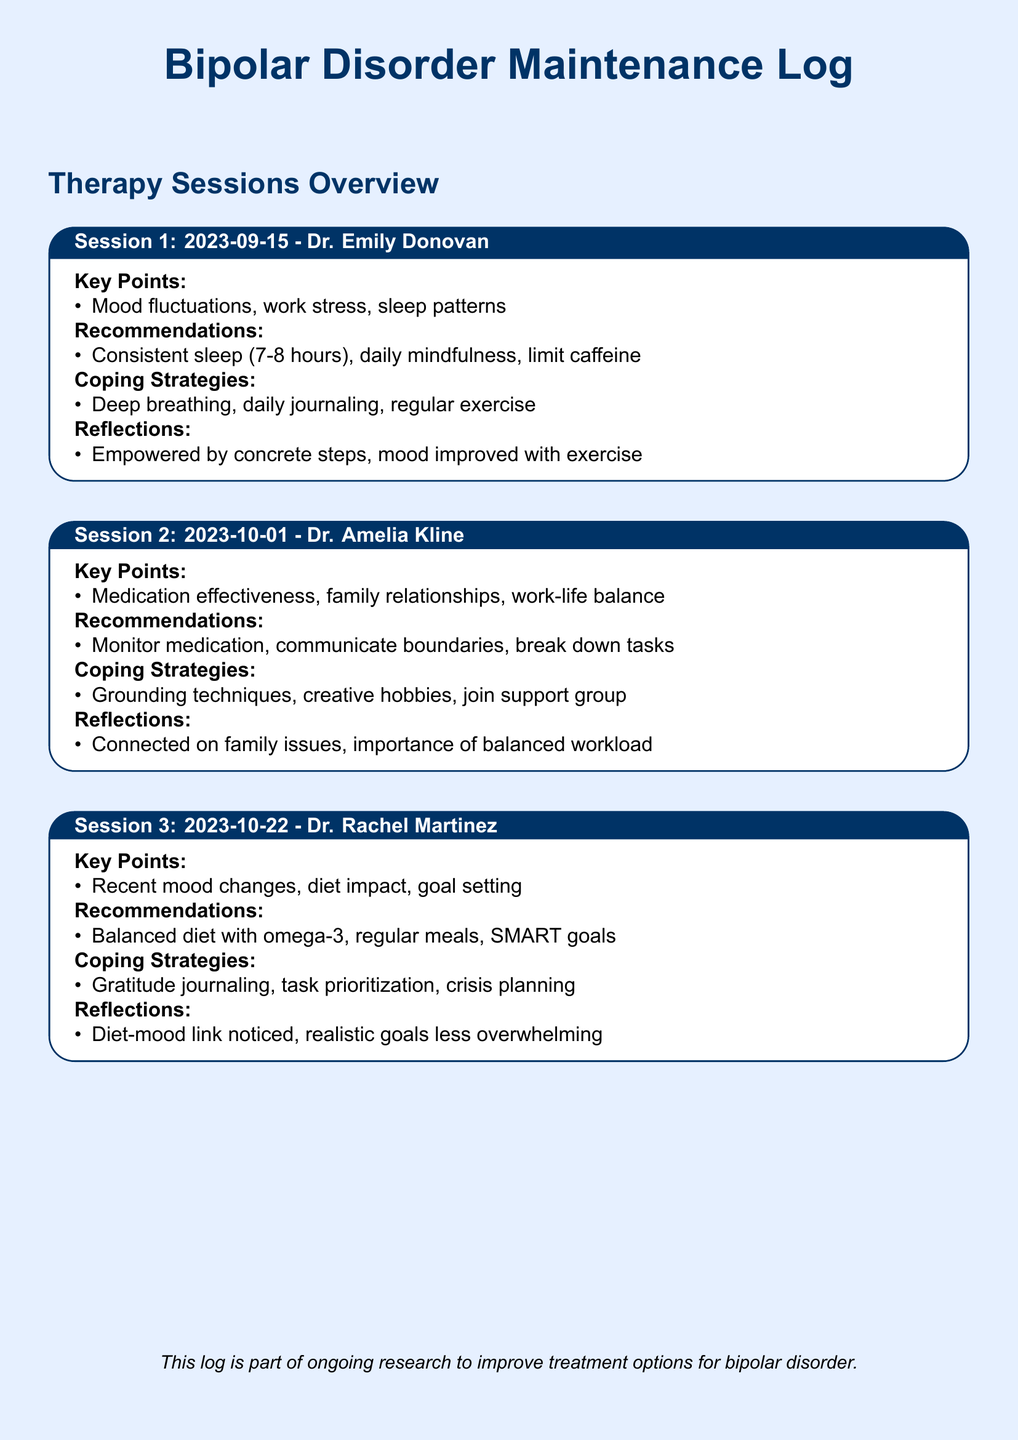What is the date of Session 1? The date is listed in the title of Session 1 in the document.
Answer: 2023-09-15 Who was the therapist for Session 2? The therapist's name is specified in the session title.
Answer: Dr. Amelia Kline What coping strategy was discussed in Session 3? The coping strategies appear in the relevant section for Session 3, detailing what was covered.
Answer: Gratitude journaling What key point was discussed in Session 2? Key points are outlined in the respective section, requiring retrieval from that area.
Answer: Medication effectiveness What recommendation was made regarding diet in Session 3? The recommendation section provides details regarding dietary suggestions during that session.
Answer: Balanced diet with omega-3 What was a personal reflection from Session 1? Reflections are specifically noted at the end of each session's box.
Answer: Empowered by concrete steps What is the focus of the overall therapy log document? The introductory note implies the purpose of the document, summarizing its aim.
Answer: Improve treatment options for bipolar disorder How many sessions are documented? The number of session boxes in the document indicates the total count of sessions held.
Answer: 3 